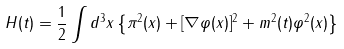Convert formula to latex. <formula><loc_0><loc_0><loc_500><loc_500>H ( t ) = \frac { 1 } { 2 } \int d ^ { 3 } x \left \{ \pi ^ { 2 } ( x ) + [ \nabla \varphi ( x ) ] ^ { 2 } + m ^ { 2 } ( t ) \varphi ^ { 2 } ( x ) \right \}</formula> 